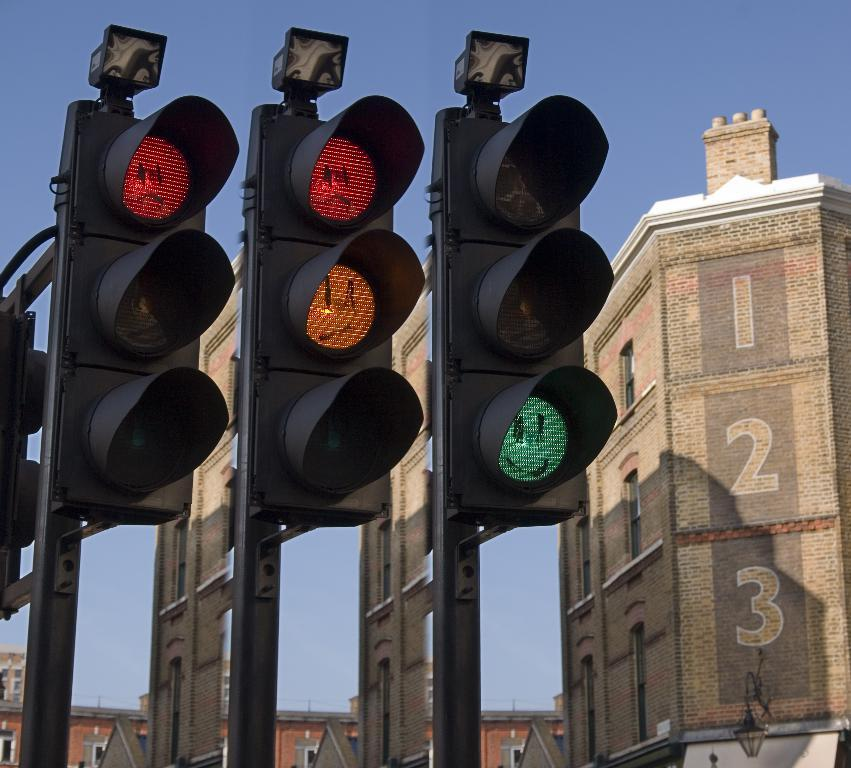<image>
Describe the image concisely. some lights next to a building with 1 2 3 on it 